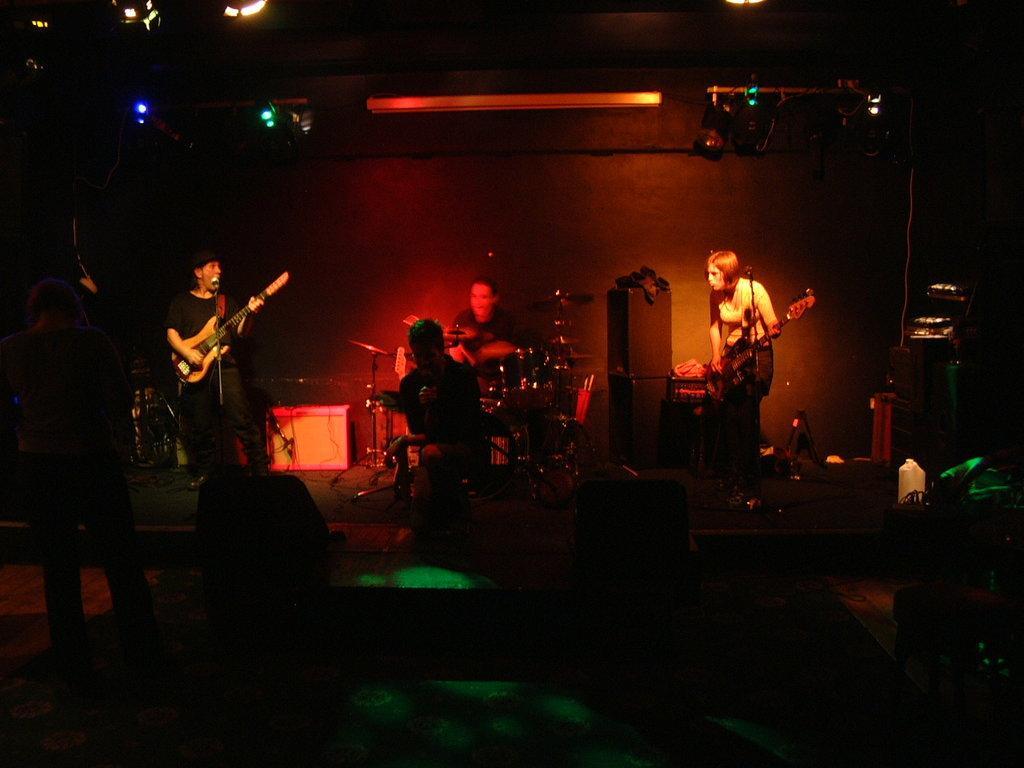How would you summarize this image in a sentence or two? In the image there are group of people who are playing their musical instruments. In middle there is a man holding a microphone and singing and we can also see another person playing his musical instrument. On right side there is a woman playing a guitar in front of a microphone, on left side there is another man playing guitar in front of a microphone. In background we can see a wall on top there are few lights. 